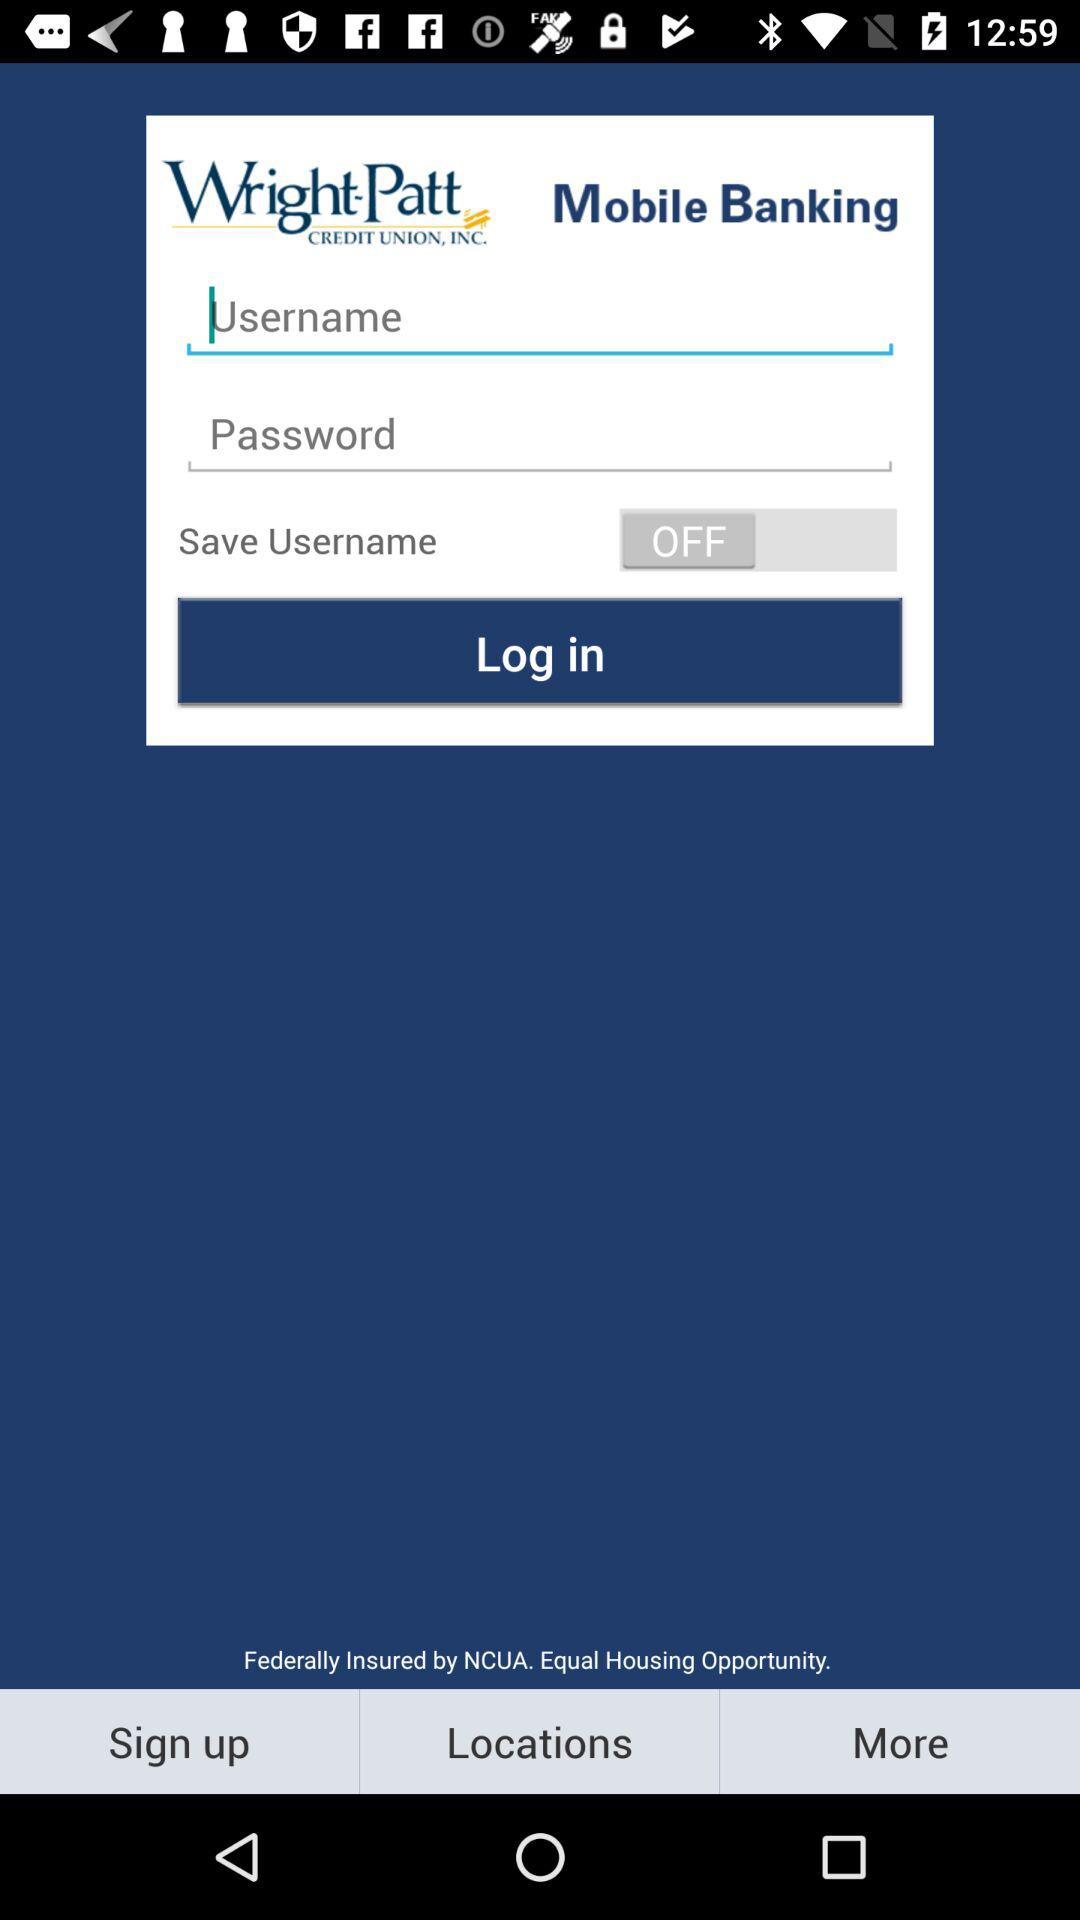Which locations are available?
When the provided information is insufficient, respond with <no answer>. <no answer> 